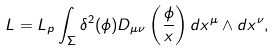<formula> <loc_0><loc_0><loc_500><loc_500>L = L _ { p } \int _ { \Sigma } \delta ^ { 2 } ( \phi ) D _ { \mu \nu } \left ( \frac { \phi } { x } \right ) d x ^ { \mu } \wedge d x ^ { \nu } ,</formula> 